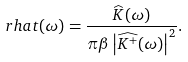Convert formula to latex. <formula><loc_0><loc_0><loc_500><loc_500>\ r h a t ( \omega ) = \frac { \widehat { K } ( \omega ) } { \pi \beta \left | \widehat { K ^ { + } } ( \omega ) \right | ^ { 2 } } .</formula> 